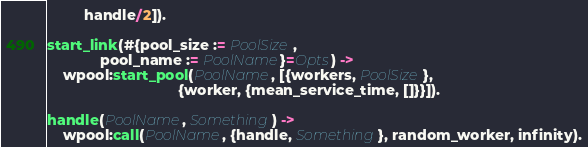Convert code to text. <code><loc_0><loc_0><loc_500><loc_500><_Erlang_>         handle/2]).

start_link(#{pool_size := PoolSize,
             pool_name := PoolName}=Opts) ->
    wpool:start_pool(PoolName, [{workers, PoolSize},
                                {worker, {mean_service_time, []}}]).

handle(PoolName, Something) ->
    wpool:call(PoolName, {handle, Something}, random_worker, infinity).
</code> 